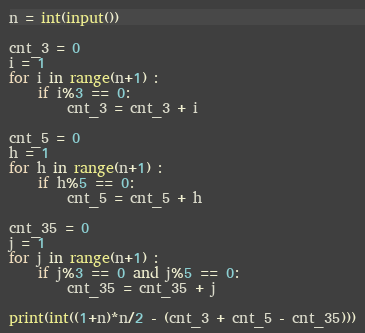<code> <loc_0><loc_0><loc_500><loc_500><_Python_>n = int(input())

cnt_3 = 0
i = 1
for i in range(n+1) :
    if i%3 == 0:
    	cnt_3 = cnt_3 + i

cnt_5 = 0
h = 1
for h in range(n+1) :
    if h%5 == 0:
    	cnt_5 = cnt_5 + h

cnt_35 = 0
j = 1
for j in range(n+1) :
    if j%3 == 0 and j%5 == 0:
    	cnt_35 = cnt_35 + j

print(int((1+n)*n/2 - (cnt_3 + cnt_5 - cnt_35)))
</code> 